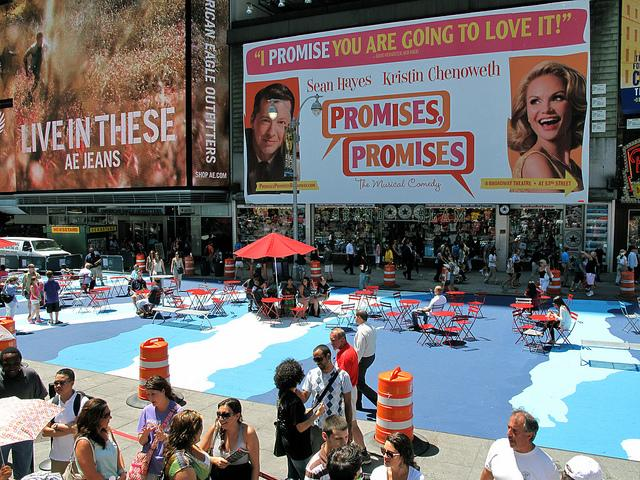What type traffic is allowed to go through this street at this time?

Choices:
A) foot only
B) all
C) buses
D) motorcycles foot only 